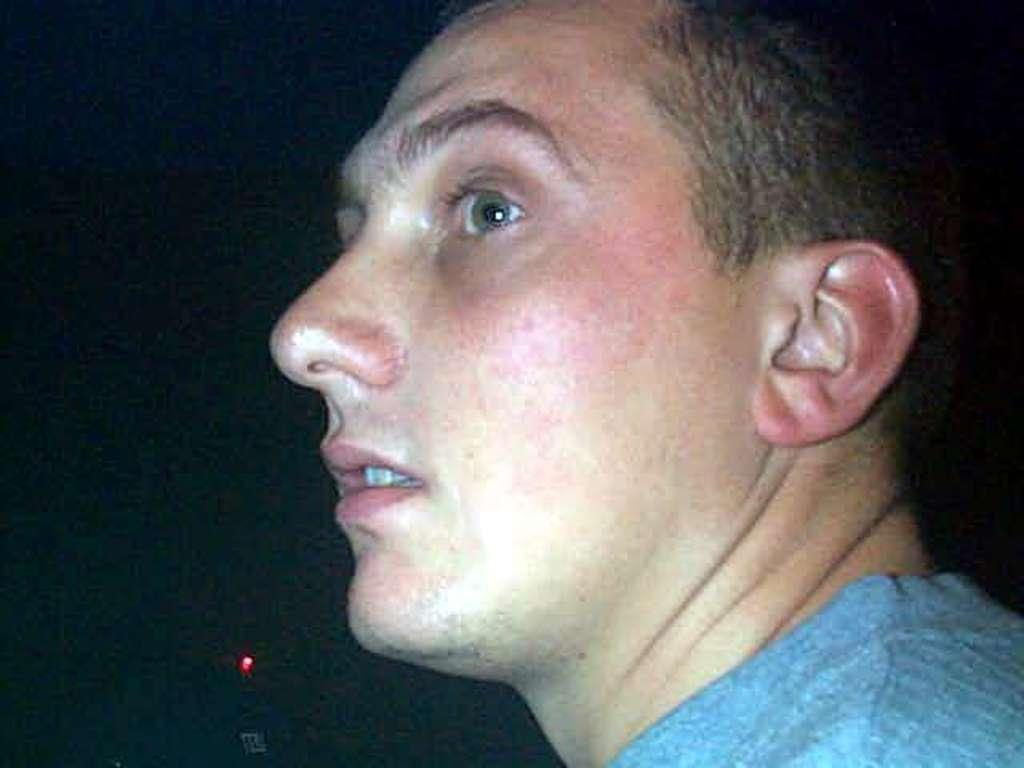Who is present in the image? There is a man in the image. Can you describe the background of the image? There is a light background and a dark background in the image. What type of pies is the man holding in the image? There is no mention of pies or any food item in the image; the man is not holding anything. 